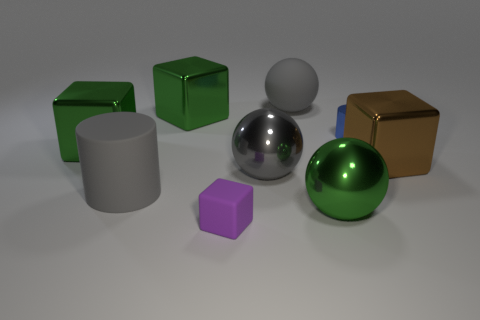Add 1 large yellow rubber cylinders. How many objects exist? 10 Subtract all cylinders. How many objects are left? 7 Subtract 0 blue blocks. How many objects are left? 9 Subtract all large gray cylinders. Subtract all large cylinders. How many objects are left? 7 Add 7 tiny blue cylinders. How many tiny blue cylinders are left? 8 Add 4 tiny blue cylinders. How many tiny blue cylinders exist? 5 